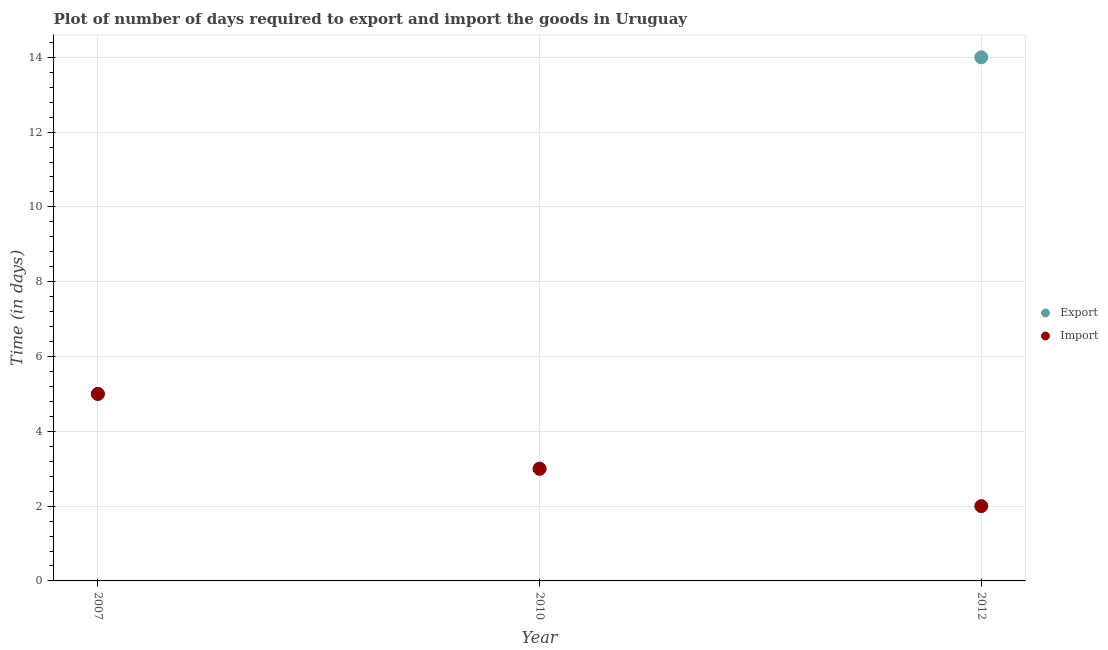How many different coloured dotlines are there?
Your response must be concise. 2. What is the time required to import in 2012?
Provide a succinct answer. 2. Across all years, what is the maximum time required to export?
Offer a very short reply. 14. Across all years, what is the minimum time required to export?
Give a very brief answer. 3. In which year was the time required to export maximum?
Your answer should be compact. 2012. What is the total time required to export in the graph?
Ensure brevity in your answer.  22. What is the difference between the time required to import in 2007 and that in 2010?
Keep it short and to the point. 2. What is the difference between the time required to import in 2010 and the time required to export in 2012?
Offer a very short reply. -11. What is the average time required to export per year?
Keep it short and to the point. 7.33. In how many years, is the time required to export greater than 6.8 days?
Your response must be concise. 1. What is the ratio of the time required to import in 2007 to that in 2010?
Give a very brief answer. 1.67. Is the difference between the time required to import in 2007 and 2012 greater than the difference between the time required to export in 2007 and 2012?
Keep it short and to the point. Yes. What is the difference between the highest and the lowest time required to import?
Make the answer very short. 3. Is the time required to import strictly less than the time required to export over the years?
Ensure brevity in your answer.  No. How many dotlines are there?
Give a very brief answer. 2. Does the graph contain grids?
Provide a short and direct response. Yes. How are the legend labels stacked?
Provide a short and direct response. Vertical. What is the title of the graph?
Your answer should be compact. Plot of number of days required to export and import the goods in Uruguay. Does "Lower secondary rate" appear as one of the legend labels in the graph?
Provide a succinct answer. No. What is the label or title of the X-axis?
Ensure brevity in your answer.  Year. What is the label or title of the Y-axis?
Your answer should be compact. Time (in days). What is the Time (in days) in Export in 2010?
Make the answer very short. 3. What is the Time (in days) in Export in 2012?
Your response must be concise. 14. Across all years, what is the maximum Time (in days) in Import?
Make the answer very short. 5. Across all years, what is the minimum Time (in days) of Export?
Give a very brief answer. 3. Across all years, what is the minimum Time (in days) in Import?
Make the answer very short. 2. What is the difference between the Time (in days) of Export in 2007 and that in 2010?
Your answer should be very brief. 2. What is the difference between the Time (in days) of Import in 2007 and that in 2012?
Make the answer very short. 3. What is the difference between the Time (in days) of Import in 2010 and that in 2012?
Provide a short and direct response. 1. What is the average Time (in days) of Export per year?
Keep it short and to the point. 7.33. In the year 2007, what is the difference between the Time (in days) in Export and Time (in days) in Import?
Your answer should be very brief. 0. In the year 2010, what is the difference between the Time (in days) of Export and Time (in days) of Import?
Ensure brevity in your answer.  0. What is the ratio of the Time (in days) of Export in 2007 to that in 2010?
Give a very brief answer. 1.67. What is the ratio of the Time (in days) in Export in 2007 to that in 2012?
Give a very brief answer. 0.36. What is the ratio of the Time (in days) in Export in 2010 to that in 2012?
Your answer should be compact. 0.21. What is the difference between the highest and the second highest Time (in days) in Export?
Your answer should be compact. 9. What is the difference between the highest and the second highest Time (in days) in Import?
Make the answer very short. 2. 